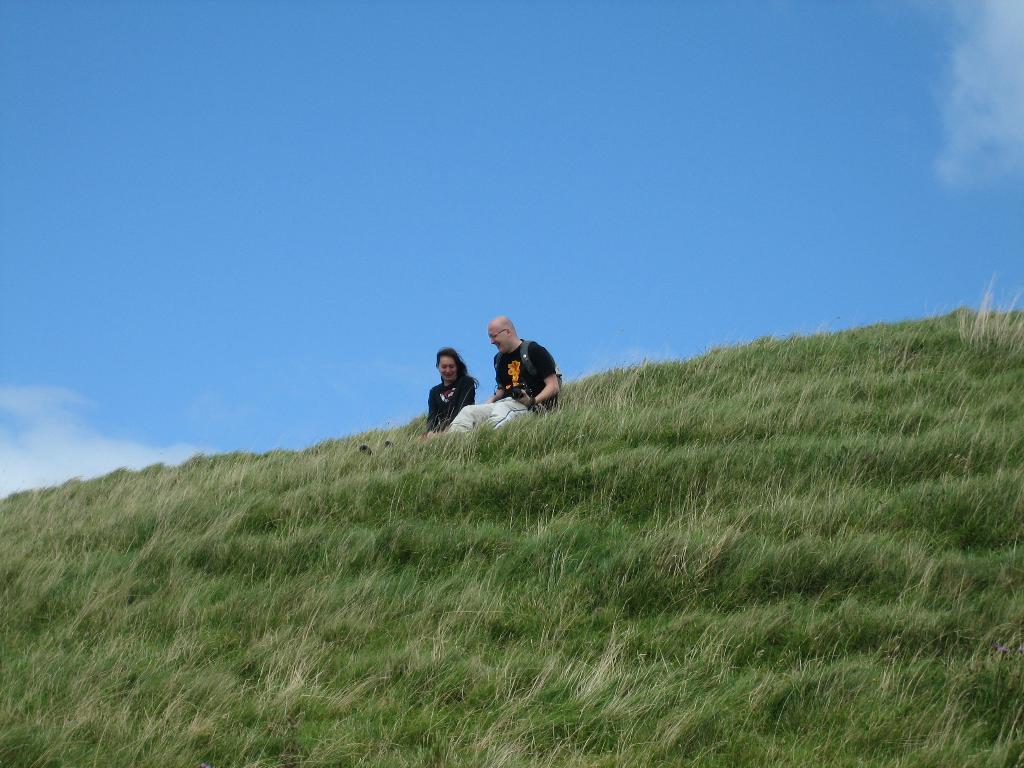Could you give a brief overview of what you see in this image? In the foreground of the image we can see the grass. In the middle of the image we can see a lady and men is sitting on the grass. On the top of the image we can see the sky. 